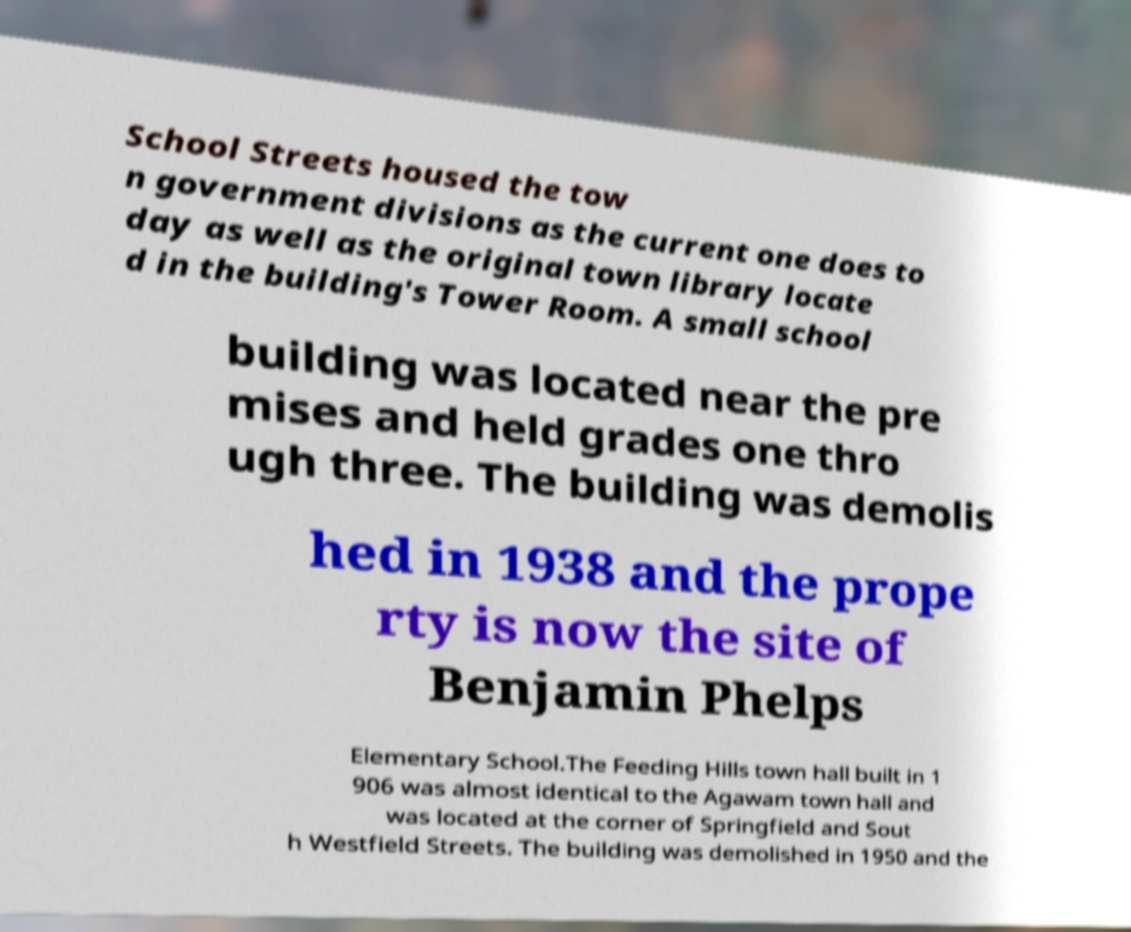Can you read and provide the text displayed in the image?This photo seems to have some interesting text. Can you extract and type it out for me? School Streets housed the tow n government divisions as the current one does to day as well as the original town library locate d in the building's Tower Room. A small school building was located near the pre mises and held grades one thro ugh three. The building was demolis hed in 1938 and the prope rty is now the site of Benjamin Phelps Elementary School.The Feeding Hills town hall built in 1 906 was almost identical to the Agawam town hall and was located at the corner of Springfield and Sout h Westfield Streets. The building was demolished in 1950 and the 